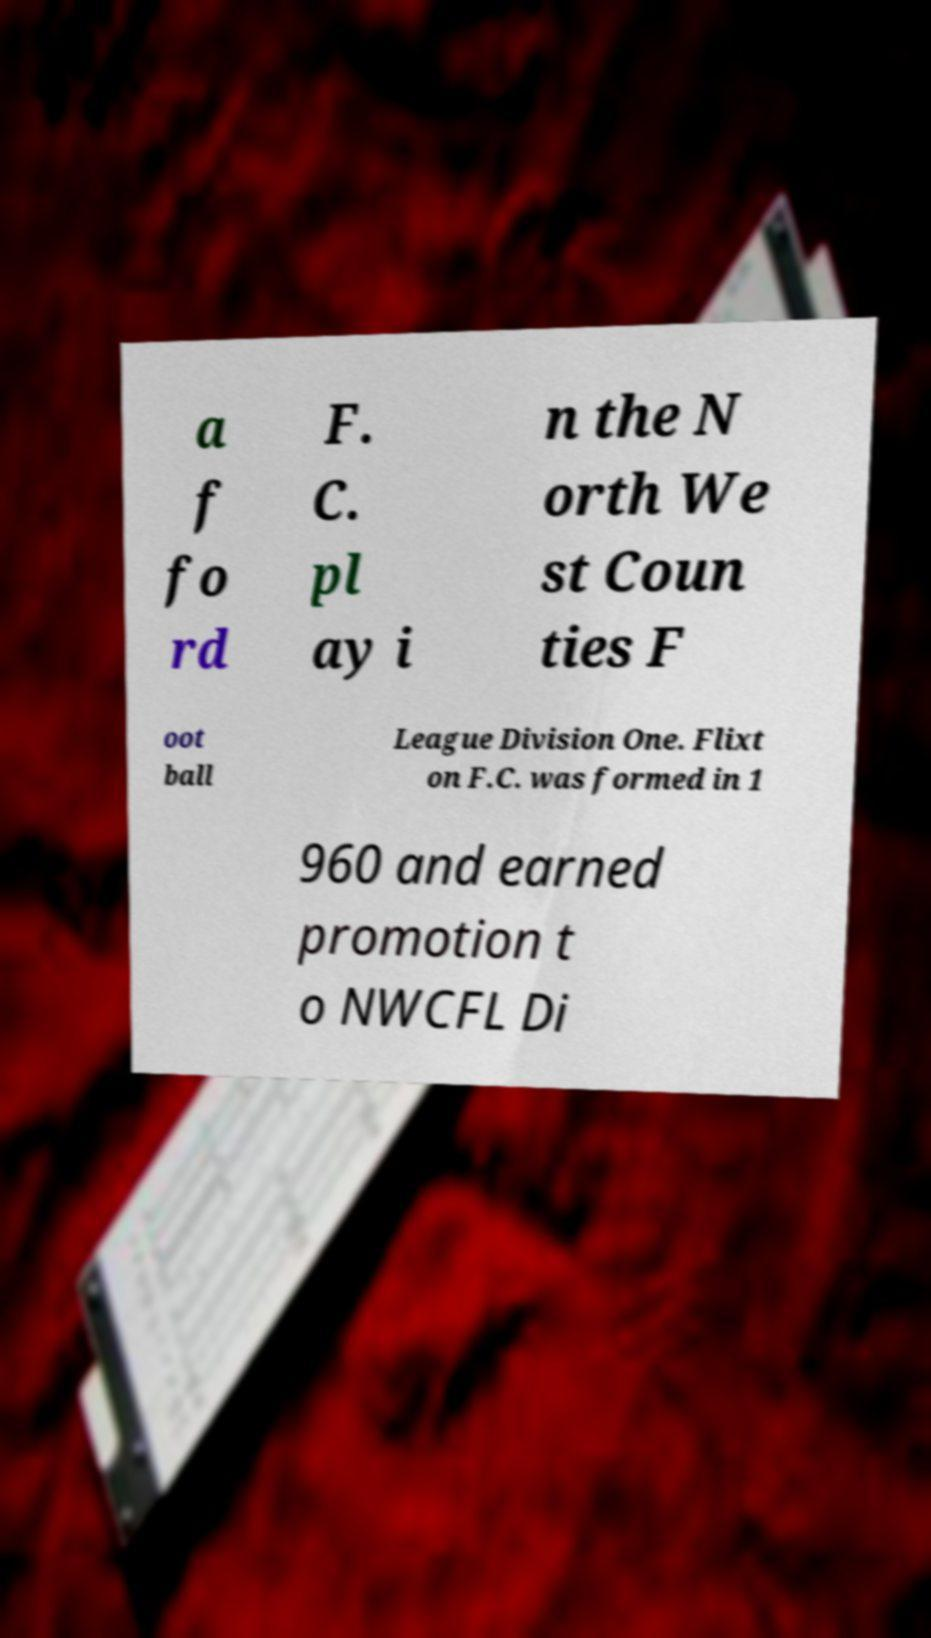For documentation purposes, I need the text within this image transcribed. Could you provide that? a f fo rd F. C. pl ay i n the N orth We st Coun ties F oot ball League Division One. Flixt on F.C. was formed in 1 960 and earned promotion t o NWCFL Di 